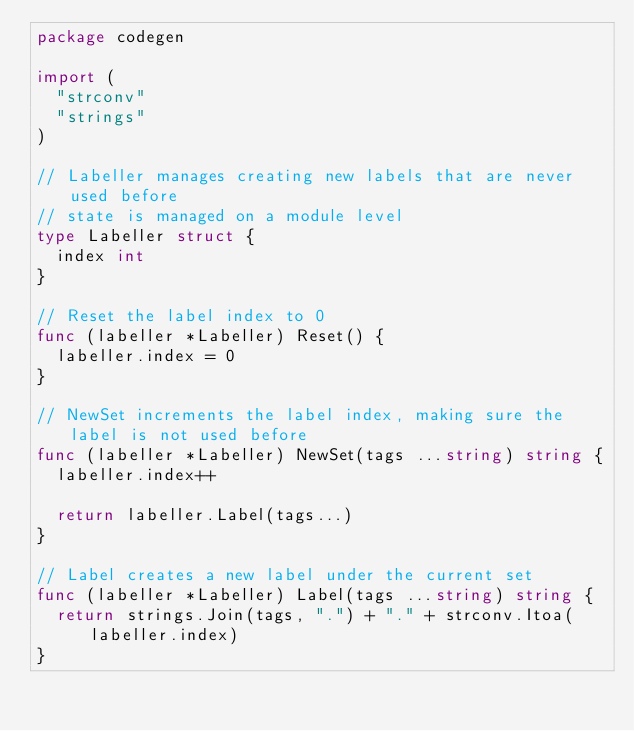<code> <loc_0><loc_0><loc_500><loc_500><_Go_>package codegen

import (
	"strconv"
	"strings"
)

// Labeller manages creating new labels that are never used before
// state is managed on a module level
type Labeller struct {
	index int
}

// Reset the label index to 0
func (labeller *Labeller) Reset() {
	labeller.index = 0
}

// NewSet increments the label index, making sure the label is not used before
func (labeller *Labeller) NewSet(tags ...string) string {
	labeller.index++

	return labeller.Label(tags...)
}

// Label creates a new label under the current set
func (labeller *Labeller) Label(tags ...string) string {
	return strings.Join(tags, ".") + "." + strconv.Itoa(labeller.index)
}
</code> 